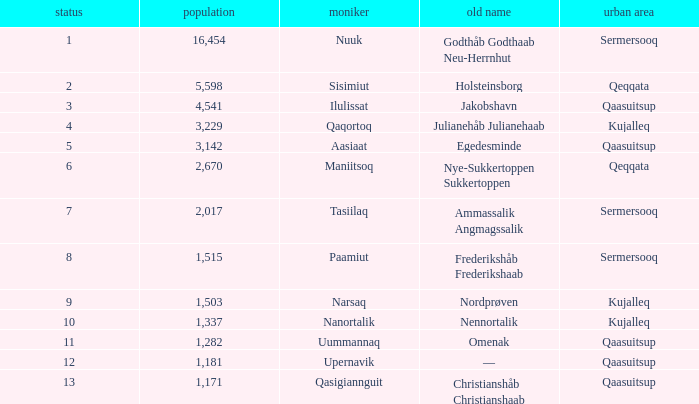What is the population for Rank 11? 1282.0. 